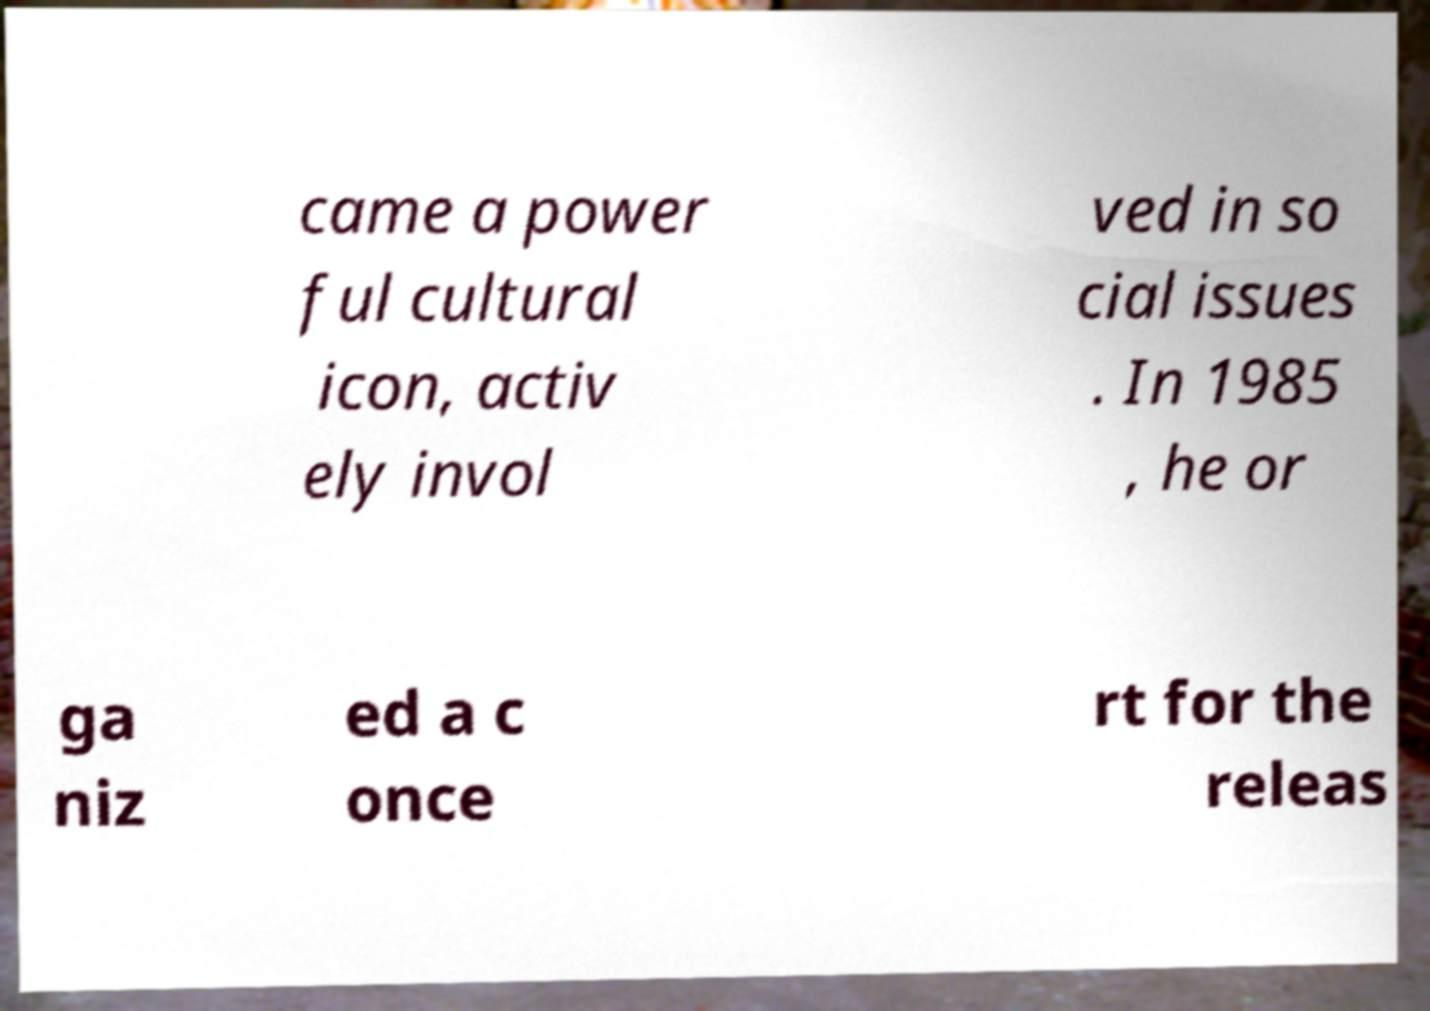Please identify and transcribe the text found in this image. came a power ful cultural icon, activ ely invol ved in so cial issues . In 1985 , he or ga niz ed a c once rt for the releas 